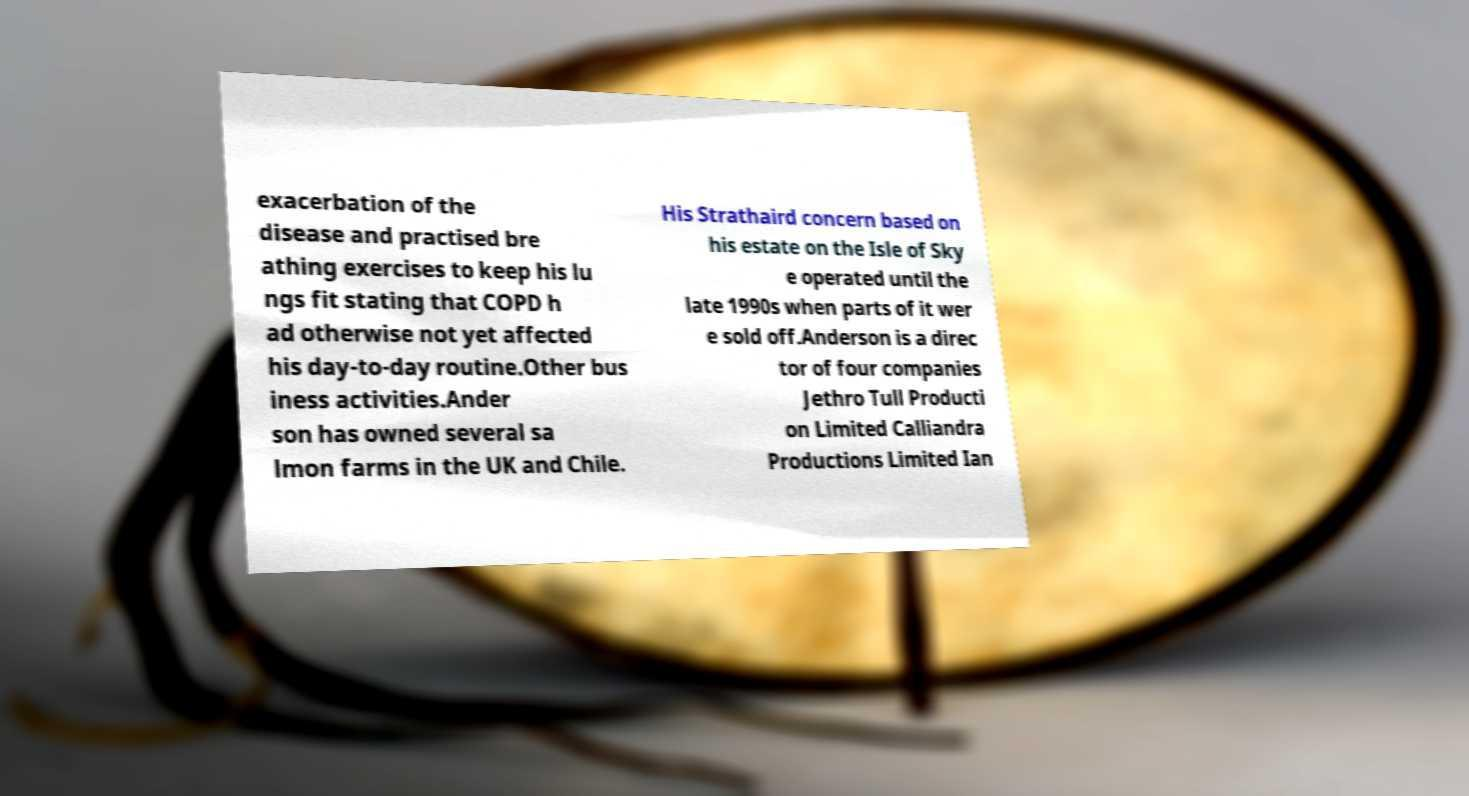There's text embedded in this image that I need extracted. Can you transcribe it verbatim? exacerbation of the disease and practised bre athing exercises to keep his lu ngs fit stating that COPD h ad otherwise not yet affected his day-to-day routine.Other bus iness activities.Ander son has owned several sa lmon farms in the UK and Chile. His Strathaird concern based on his estate on the Isle of Sky e operated until the late 1990s when parts of it wer e sold off.Anderson is a direc tor of four companies Jethro Tull Producti on Limited Calliandra Productions Limited Ian 